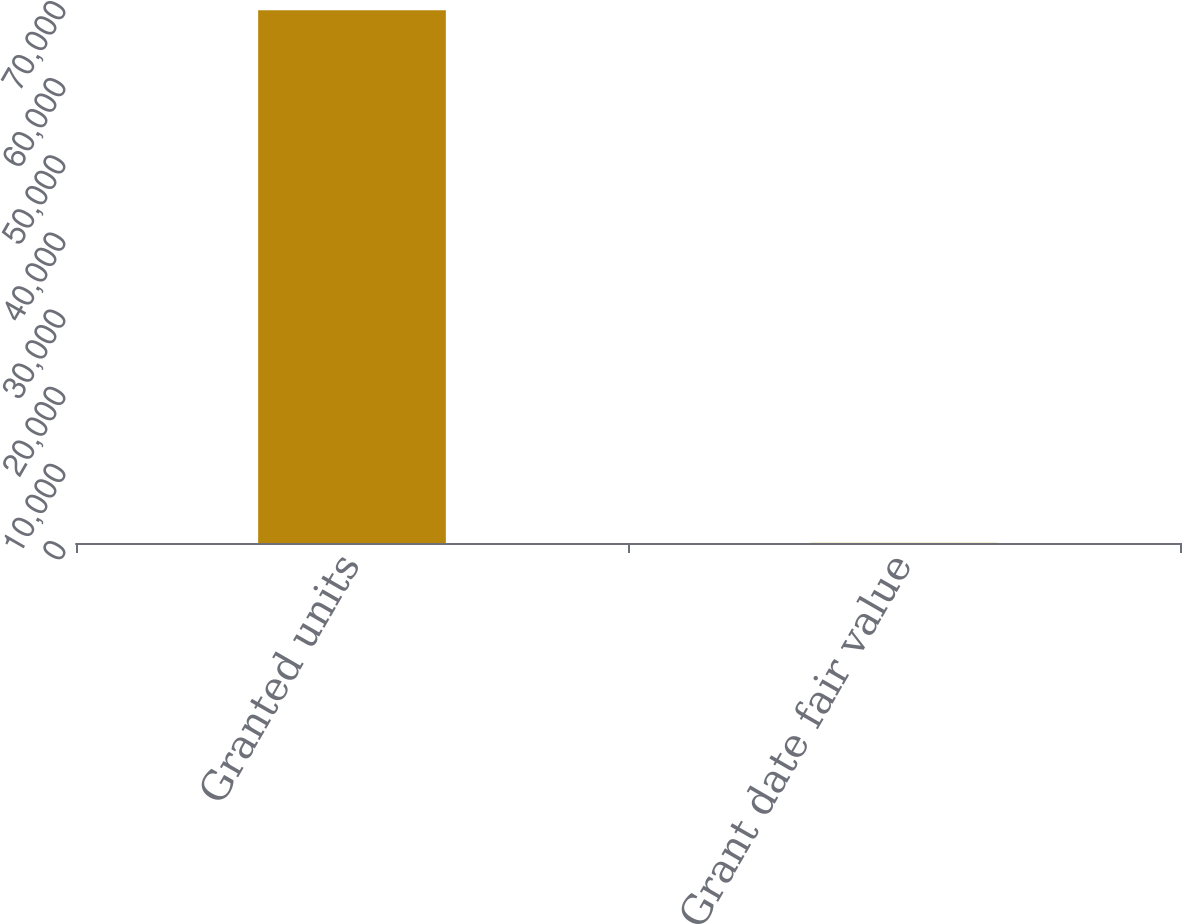Convert chart to OTSL. <chart><loc_0><loc_0><loc_500><loc_500><bar_chart><fcel>Granted units<fcel>Grant date fair value<nl><fcel>69044<fcel>22.6<nl></chart> 